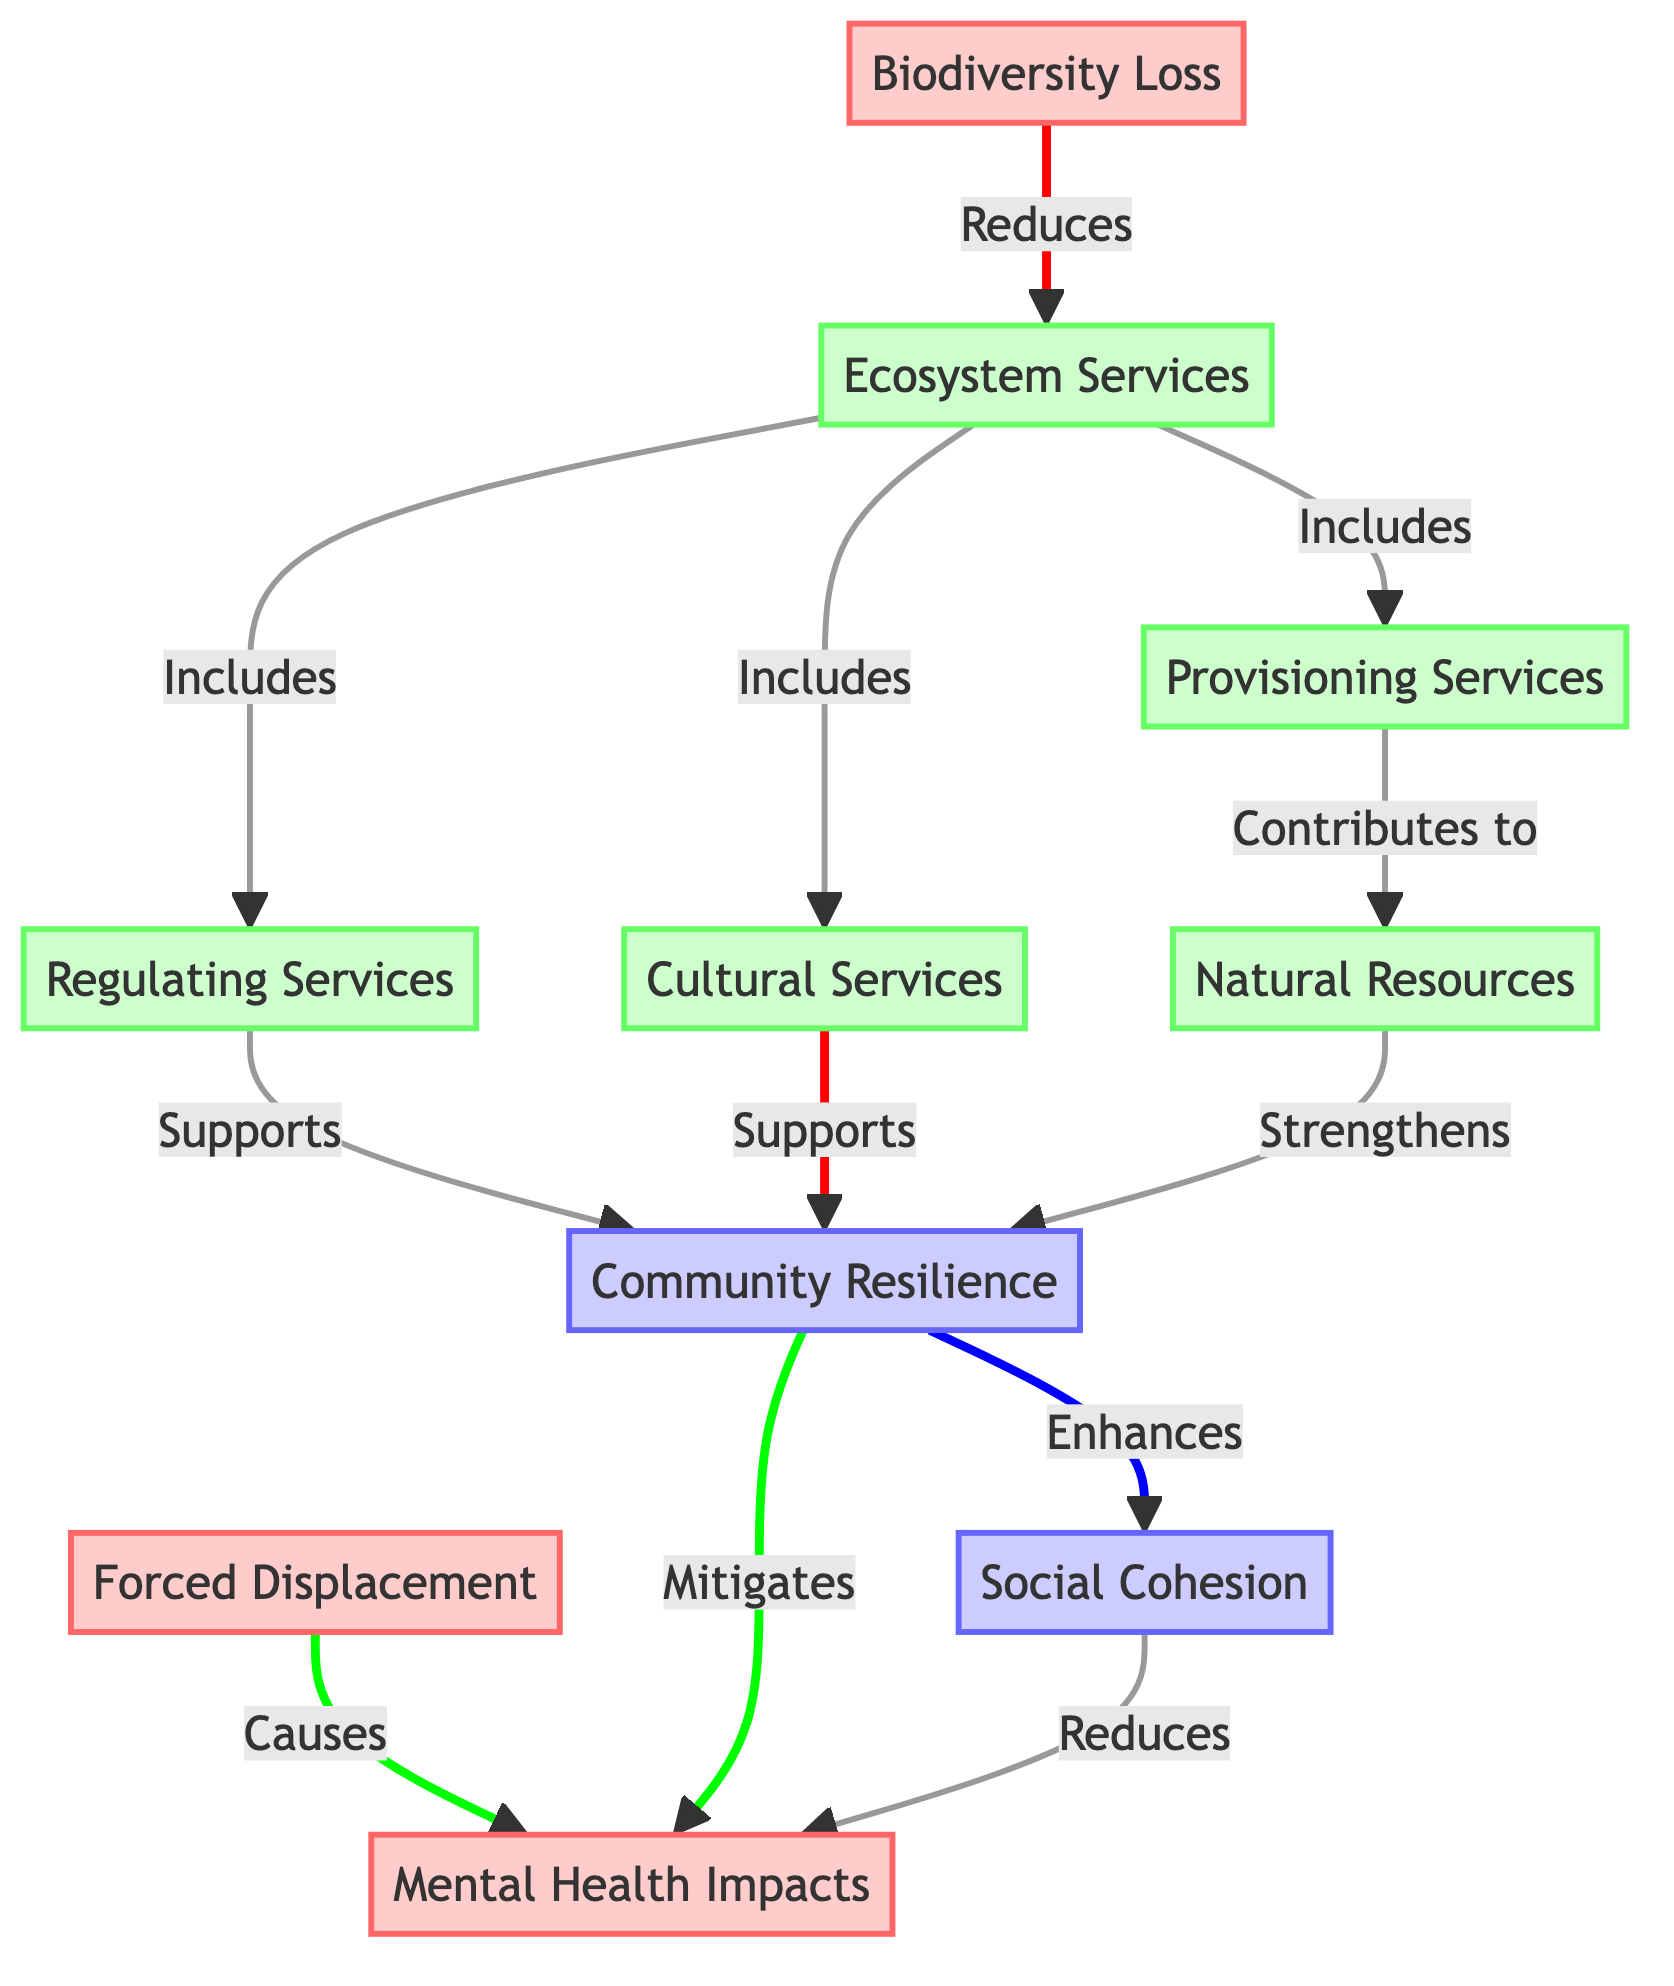What are the three types of ecosystem services listed in the diagram? The diagram indicates three types of ecosystem services connected to biodiversity loss: Provisioning Services, Regulating Services, and Cultural Services. Each service type is represented as a separate node under Ecosystem Services.
Answer: Provisioning Services, Regulating Services, Cultural Services How does biodiversity loss affect ecosystem services? The diagram demonstrates that biodiversity loss reduces ecosystem services. This is a direct connection where the arrow indicates the flow of impact from Biodiversity Loss to Ecosystem Services.
Answer: Reduces What are the effects of community resilience on mental health impacts due to forced displacement? According to the diagram, community resilience mitigates mental health impacts caused by forced displacement. This is illustrated by the link from Community Resilience to Mental Health Impacts, showing a protective role.
Answer: Mitigates How many nodes are involved in the relationship between community resilience and mental health impacts? Counting the nodes linked to the concept of mental health impacts, we see two direct influences: Community Resilience and Social Cohesion, which contribute to the effect on mental health impacts. Therefore, there are three nodes in total: Community Resilience, Social Cohesion, and Mental Health Impacts.
Answer: 3 What role do natural resources play in community resilience? The diagram shows that natural resources strengthen community resilience. This is demonstrated by an arrow from Natural Resources that points to Community Resilience, indicating a supportive relationship.
Answer: Strengthens Which node has a direct connection to both regulating services and cultural services in the diagram? The Ecosystem Services node has direct connections to both Regulating Services and Cultural Services, indicating it encompasses these two service types. This relation is clearly illustrated by the links emanating from Ecosystem Services.
Answer: Ecosystem Services What is the impact of social cohesion on mental health impacts? The diagram indicates that social cohesion reduces mental health impacts. This is illustrated by the arrow from Social Cohesion pointing towards Mental Health Impacts, showing how strong social ties can alleviate mental health issues.
Answer: Reduces How many edges connect biodiversity loss to ecosystem services? There is one direct edge connecting Biodiversity Loss to Ecosystem Services, as illustrated by the arrow that flows directly from the Biodiversity Loss node to the Ecosystem Services node.
Answer: 1 